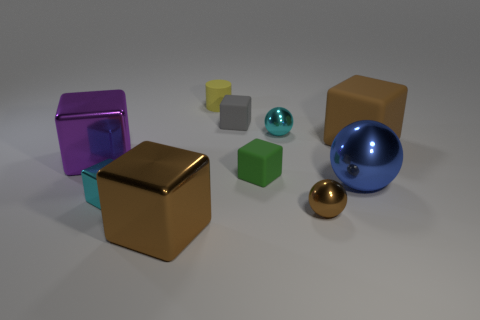Subtract all brown blocks. How many blocks are left? 4 Subtract all blue balls. How many balls are left? 2 Subtract 3 blocks. How many blocks are left? 3 Subtract all cyan balls. Subtract all blue cylinders. How many balls are left? 2 Subtract all gray cubes. How many blue spheres are left? 1 Subtract all rubber cylinders. Subtract all big red balls. How many objects are left? 9 Add 5 tiny cyan metallic spheres. How many tiny cyan metallic spheres are left? 6 Add 4 small green blocks. How many small green blocks exist? 5 Subtract 1 green blocks. How many objects are left? 9 Subtract all cubes. How many objects are left? 4 